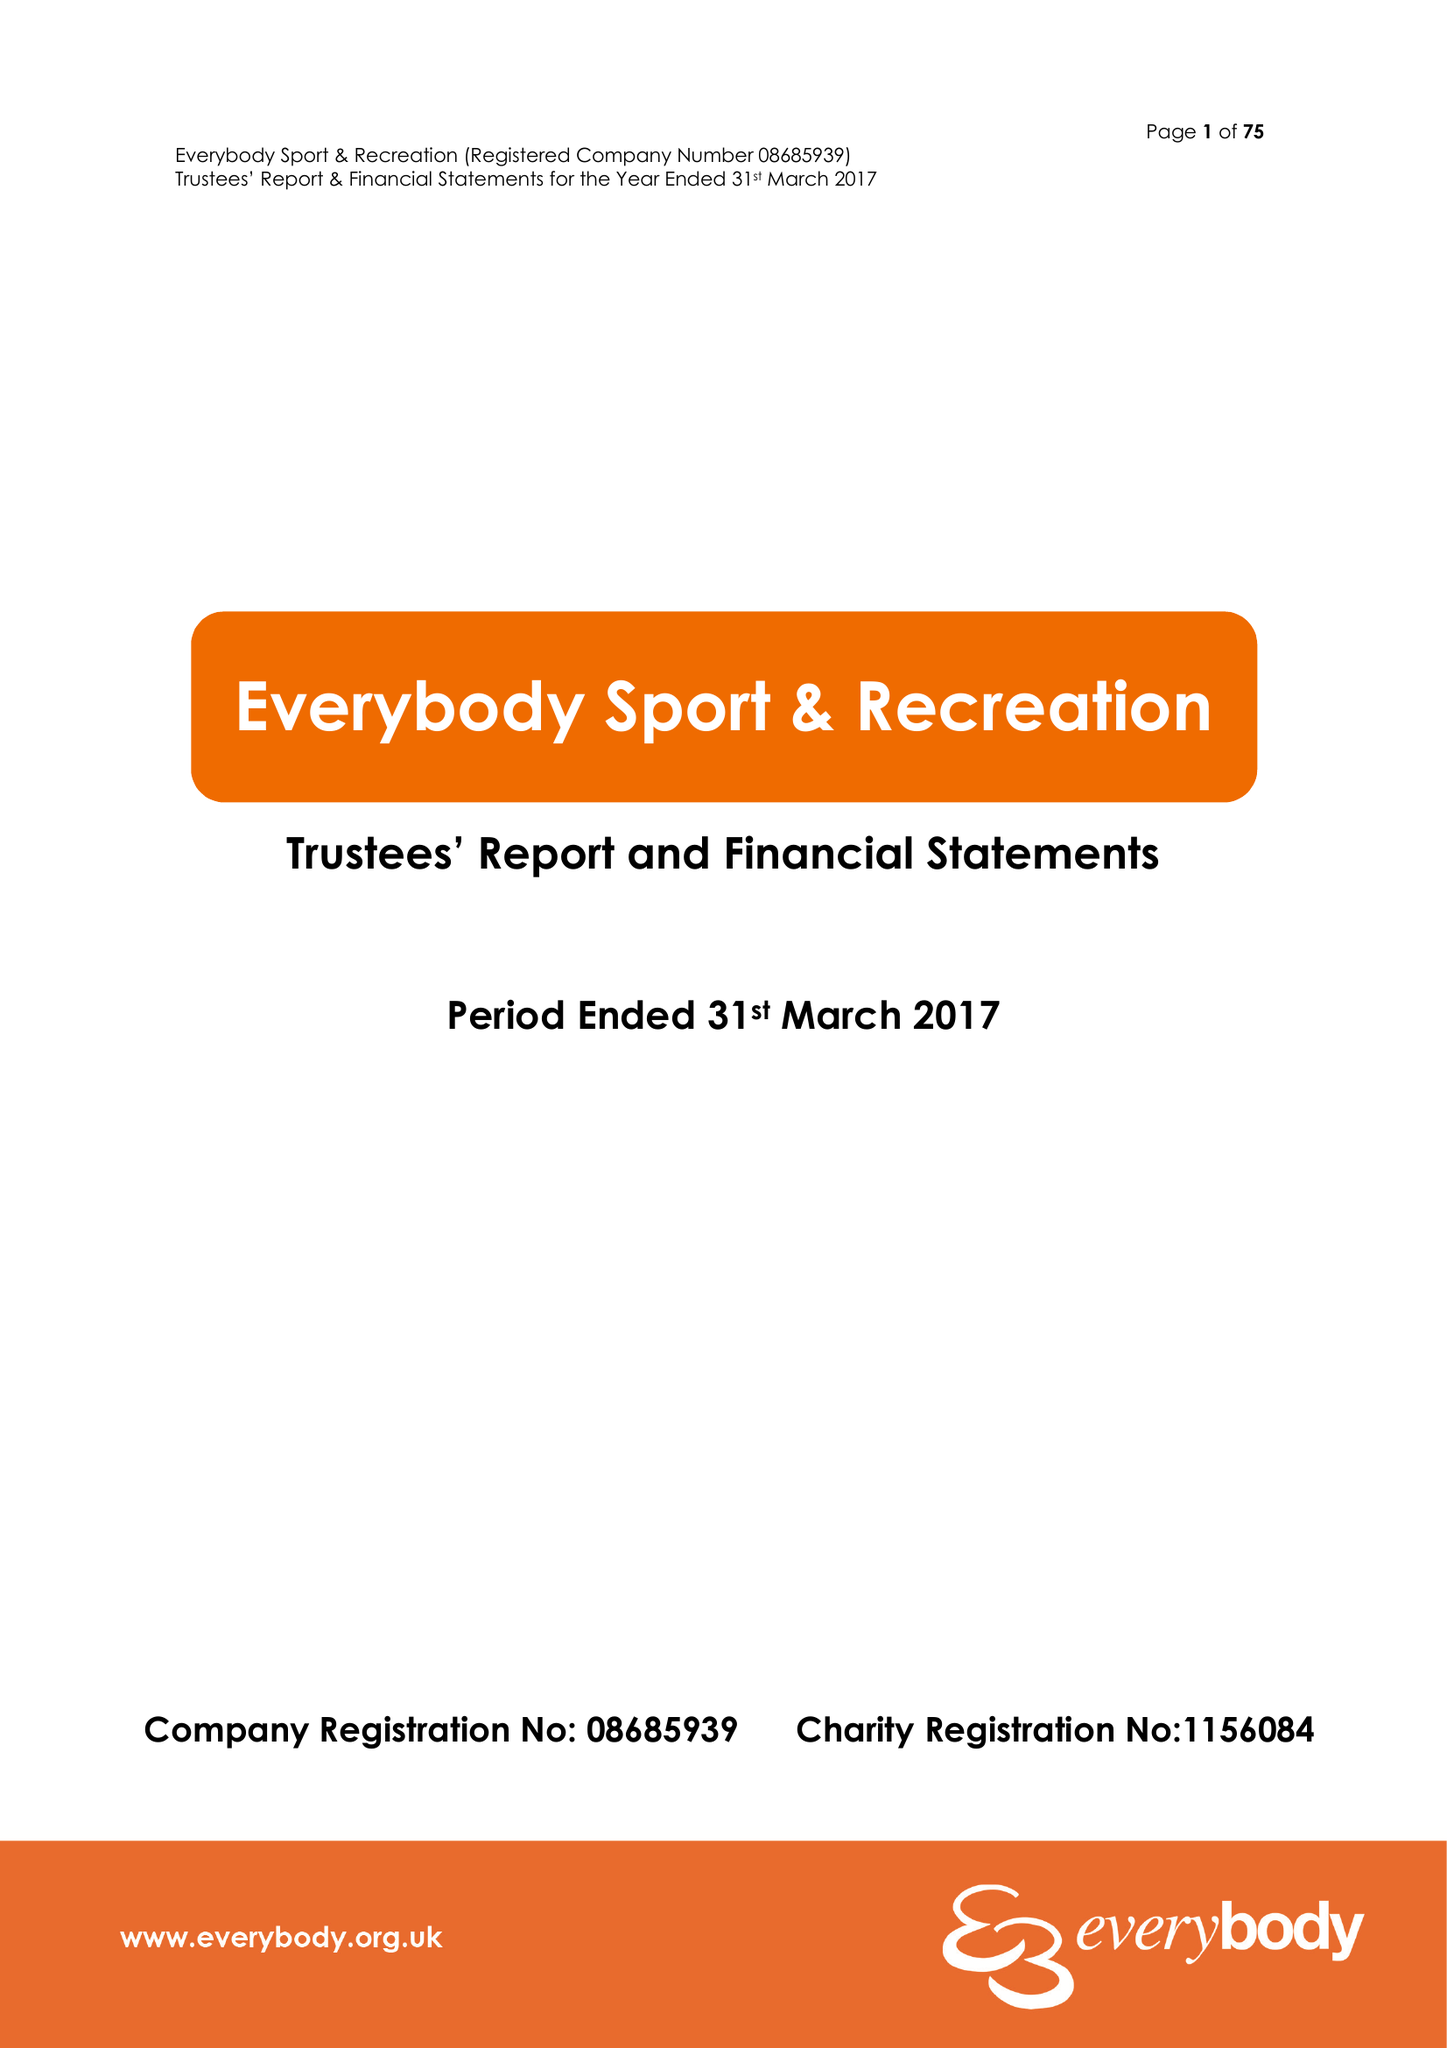What is the value for the address__post_town?
Answer the question using a single word or phrase. CREWE 